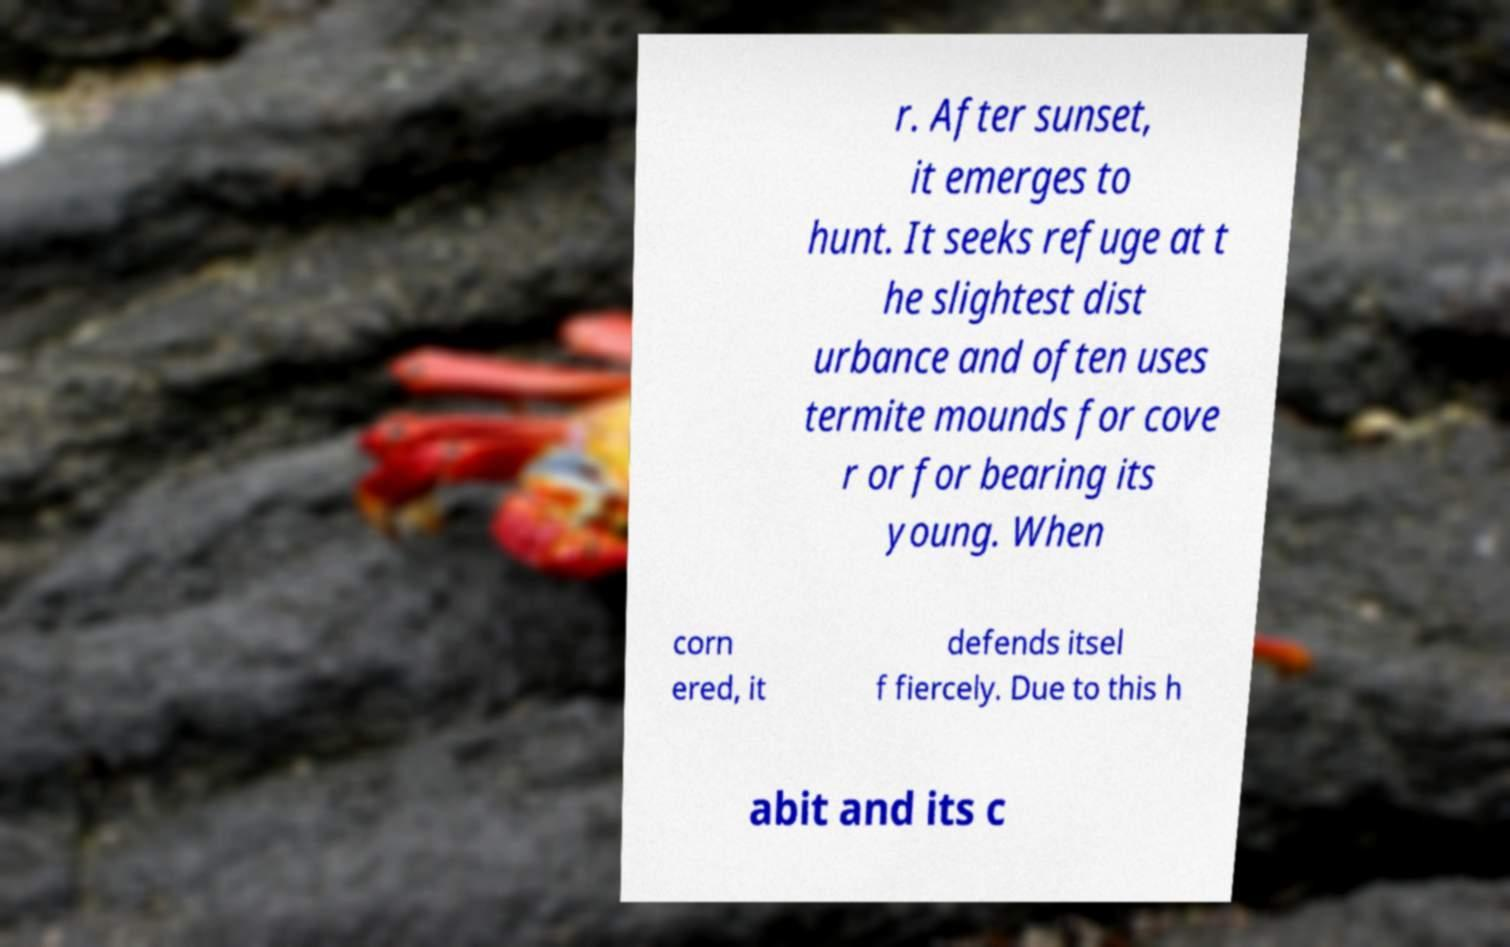For documentation purposes, I need the text within this image transcribed. Could you provide that? r. After sunset, it emerges to hunt. It seeks refuge at t he slightest dist urbance and often uses termite mounds for cove r or for bearing its young. When corn ered, it defends itsel f fiercely. Due to this h abit and its c 